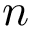Convert formula to latex. <formula><loc_0><loc_0><loc_500><loc_500>n</formula> 